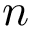Convert formula to latex. <formula><loc_0><loc_0><loc_500><loc_500>n</formula> 